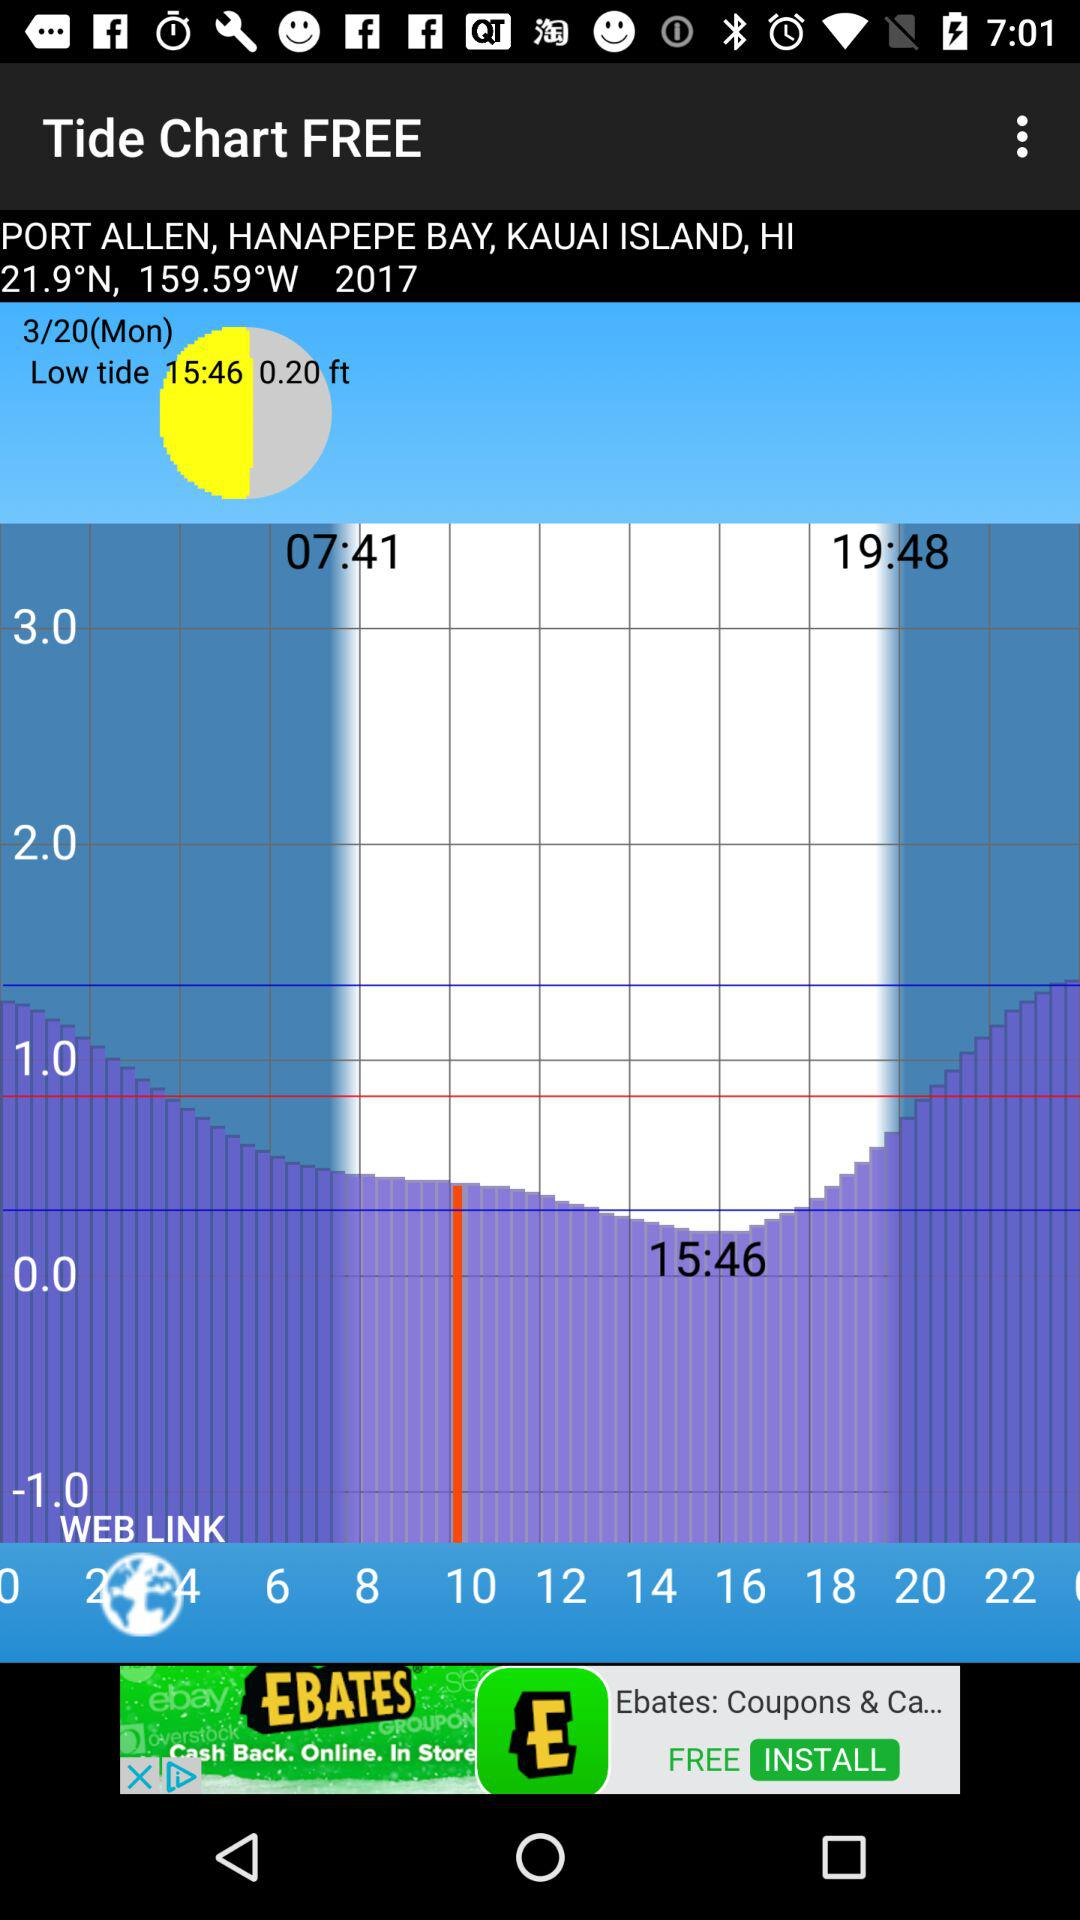What is the selected date? The selected date is Monday, March 20. 